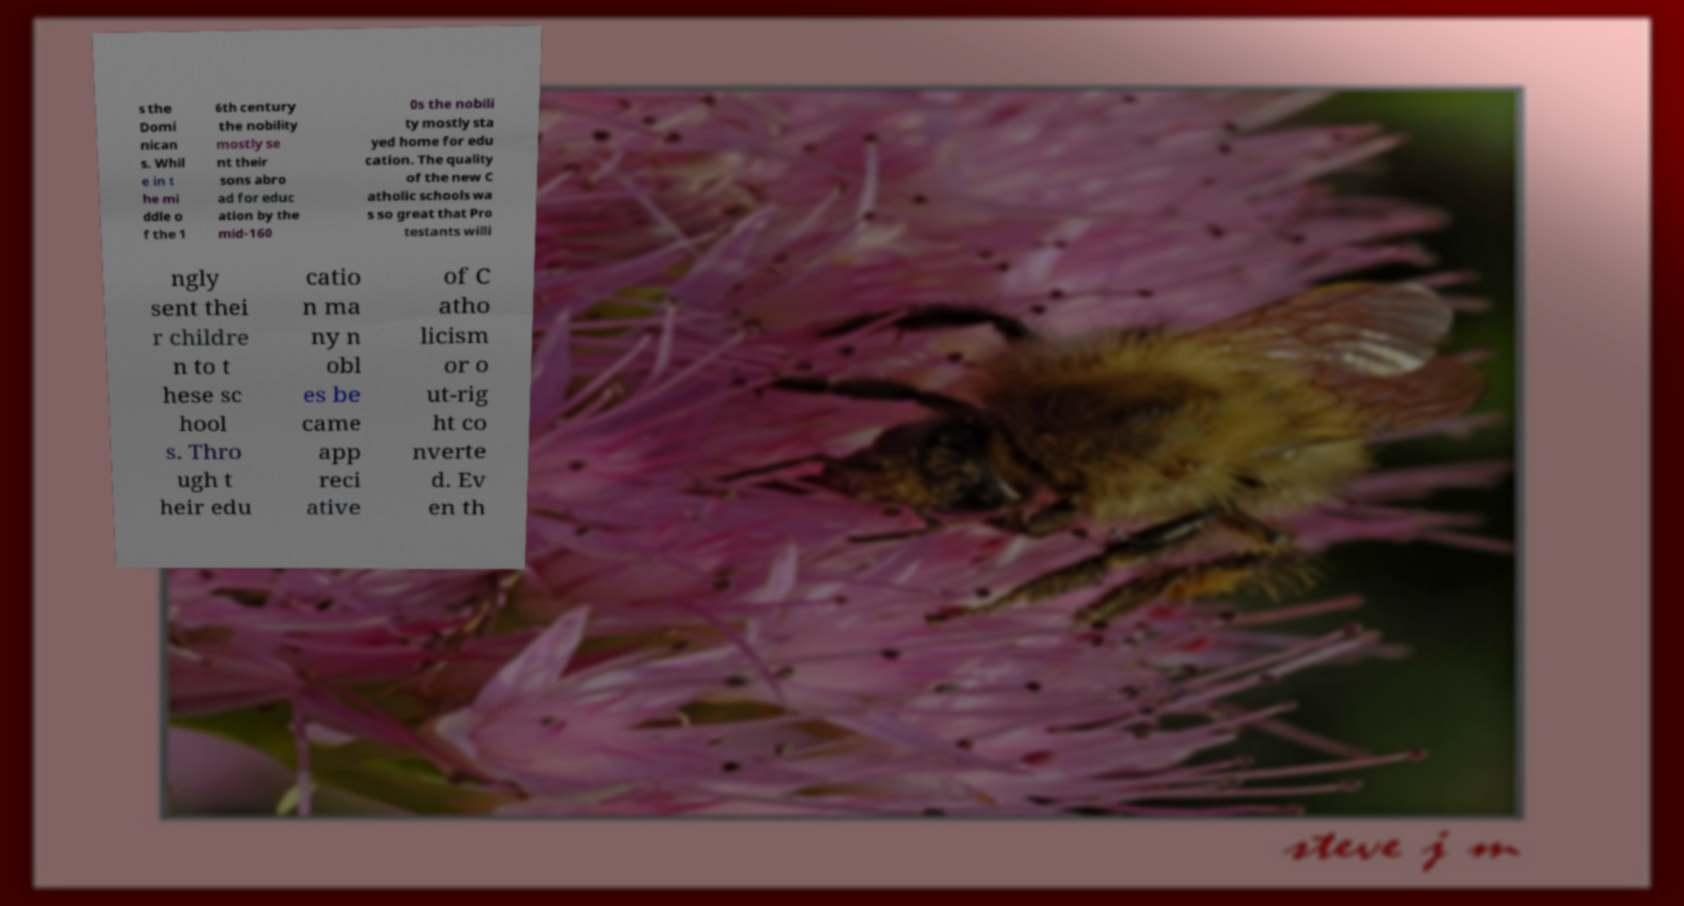Can you read and provide the text displayed in the image?This photo seems to have some interesting text. Can you extract and type it out for me? s the Domi nican s. Whil e in t he mi ddle o f the 1 6th century the nobility mostly se nt their sons abro ad for educ ation by the mid-160 0s the nobili ty mostly sta yed home for edu cation. The quality of the new C atholic schools wa s so great that Pro testants willi ngly sent thei r childre n to t hese sc hool s. Thro ugh t heir edu catio n ma ny n obl es be came app reci ative of C atho licism or o ut-rig ht co nverte d. Ev en th 